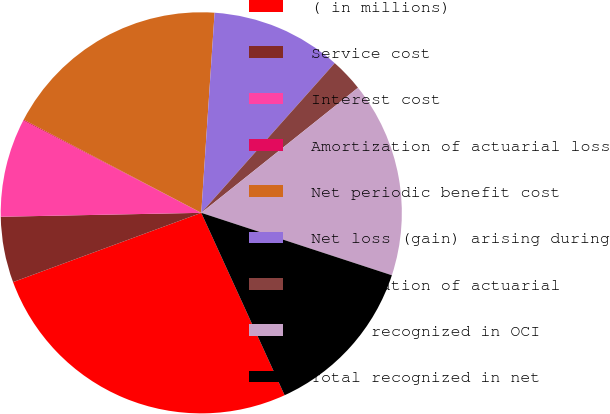<chart> <loc_0><loc_0><loc_500><loc_500><pie_chart><fcel>( in millions)<fcel>Service cost<fcel>Interest cost<fcel>Amortization of actuarial loss<fcel>Net periodic benefit cost<fcel>Net loss (gain) arising during<fcel>Amortization of actuarial<fcel>Total recognized in OCI<fcel>Total recognized in net<nl><fcel>26.21%<fcel>5.3%<fcel>7.92%<fcel>0.08%<fcel>18.37%<fcel>10.53%<fcel>2.69%<fcel>15.76%<fcel>13.14%<nl></chart> 